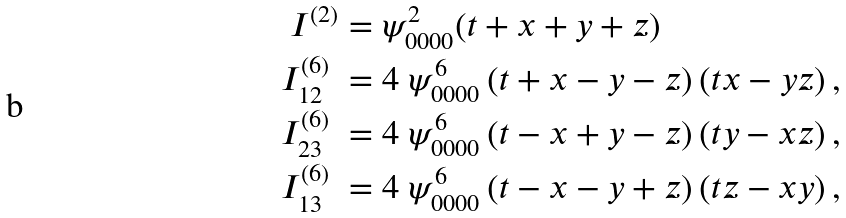<formula> <loc_0><loc_0><loc_500><loc_500>I ^ { ( 2 ) } & = \psi _ { 0 0 0 0 } ^ { 2 } ( t + x + y + z ) \\ I _ { 1 2 } ^ { ( 6 ) } \ & = 4 \ \psi _ { 0 0 0 0 } ^ { 6 } \left ( t + x - y - z \right ) ( t x - y z ) \, , \\ I _ { 2 3 } ^ { ( 6 ) } \ & = 4 \ \psi _ { 0 0 0 0 } ^ { 6 } \left ( t - x + y - z \right ) ( t y - x z ) \, , \\ I _ { 1 3 } ^ { ( 6 ) } \ & = 4 \ \psi _ { 0 0 0 0 } ^ { 6 } \left ( t - x - y + z \right ) ( t z - x y ) \, ,</formula> 